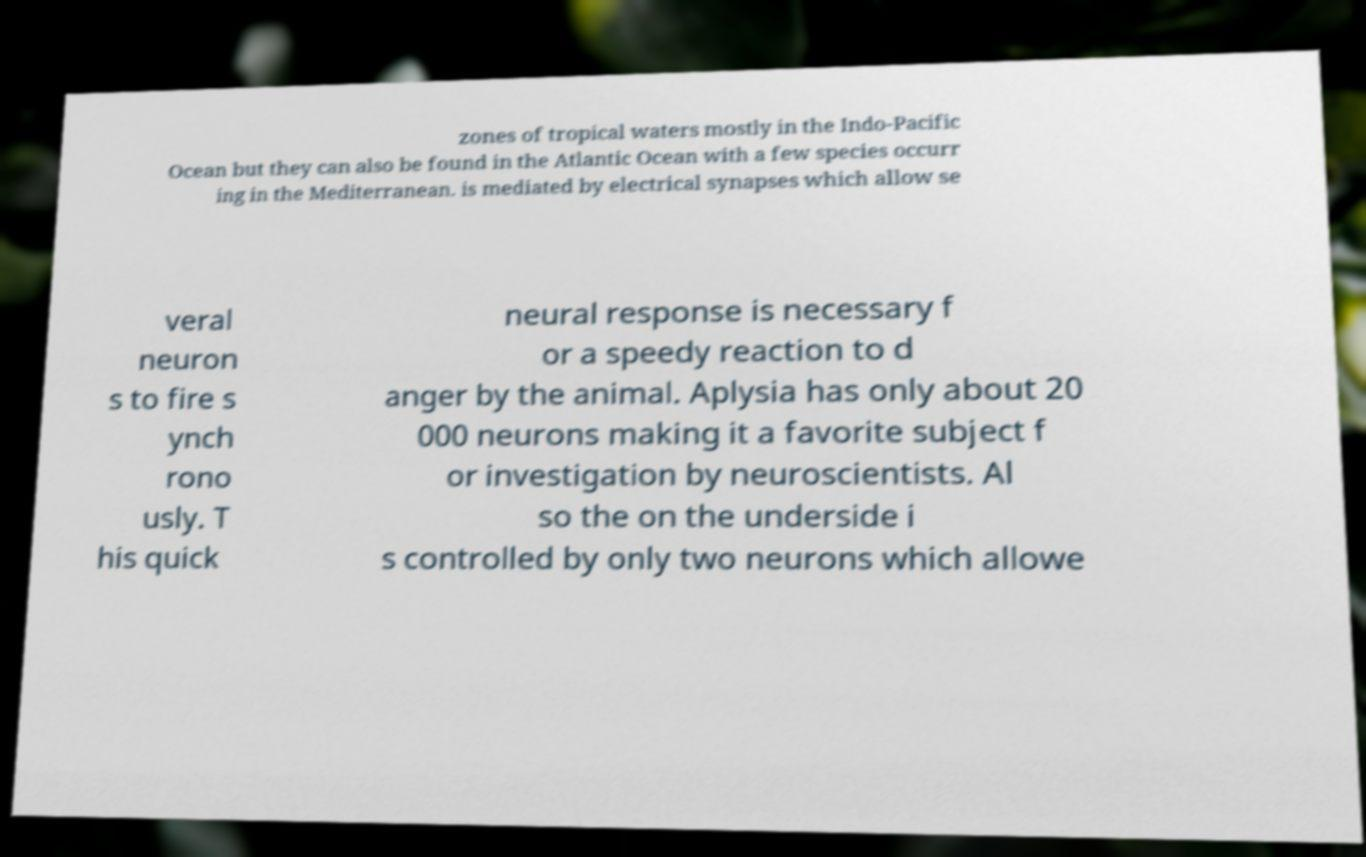Could you assist in decoding the text presented in this image and type it out clearly? zones of tropical waters mostly in the Indo-Pacific Ocean but they can also be found in the Atlantic Ocean with a few species occurr ing in the Mediterranean. is mediated by electrical synapses which allow se veral neuron s to fire s ynch rono usly. T his quick neural response is necessary f or a speedy reaction to d anger by the animal. Aplysia has only about 20 000 neurons making it a favorite subject f or investigation by neuroscientists. Al so the on the underside i s controlled by only two neurons which allowe 